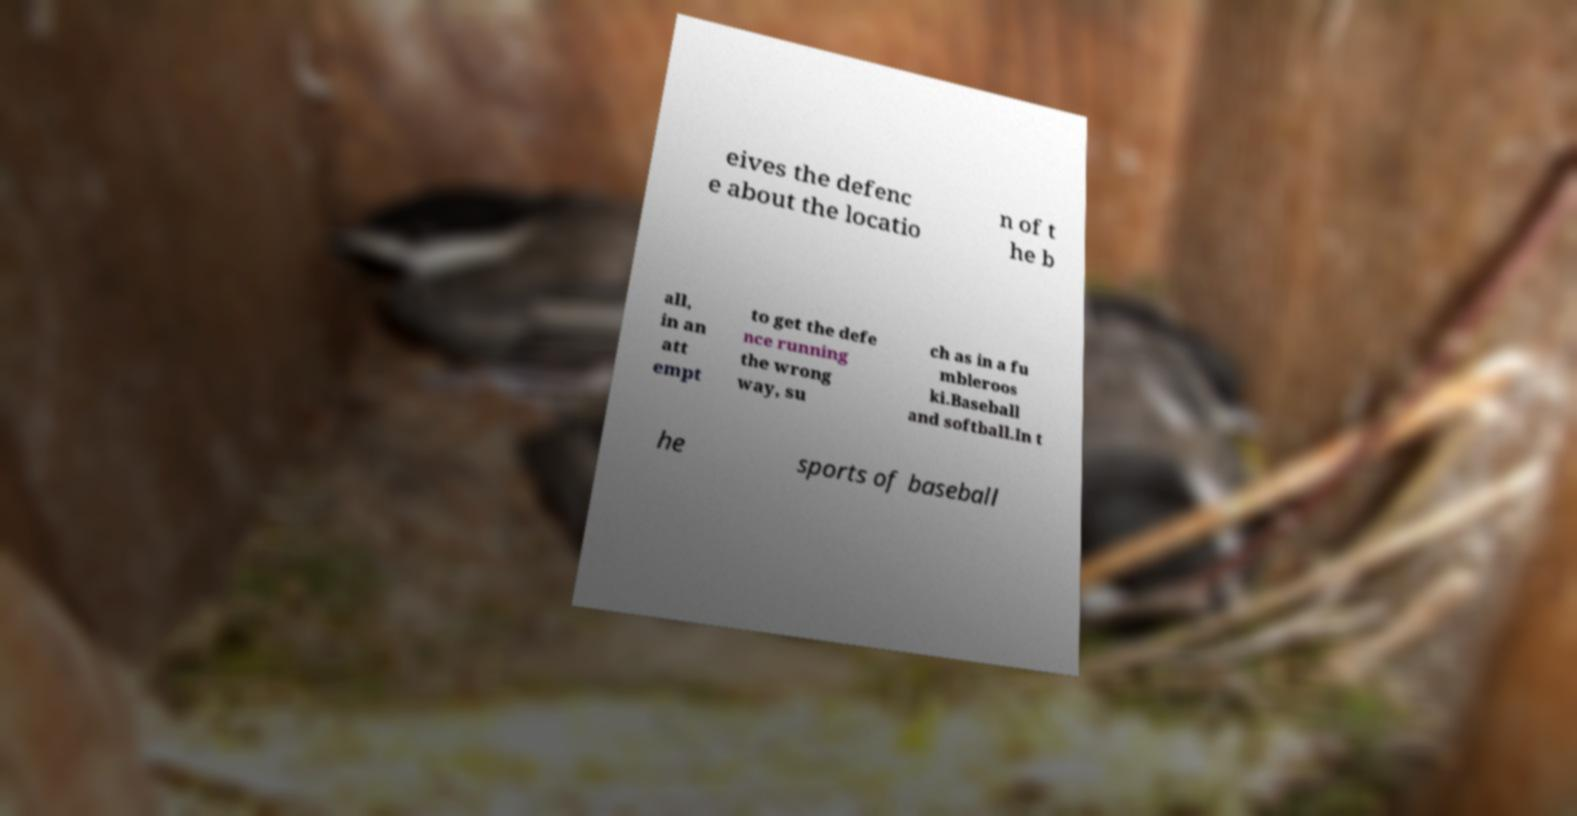There's text embedded in this image that I need extracted. Can you transcribe it verbatim? eives the defenc e about the locatio n of t he b all, in an att empt to get the defe nce running the wrong way, su ch as in a fu mbleroos ki.Baseball and softball.In t he sports of baseball 